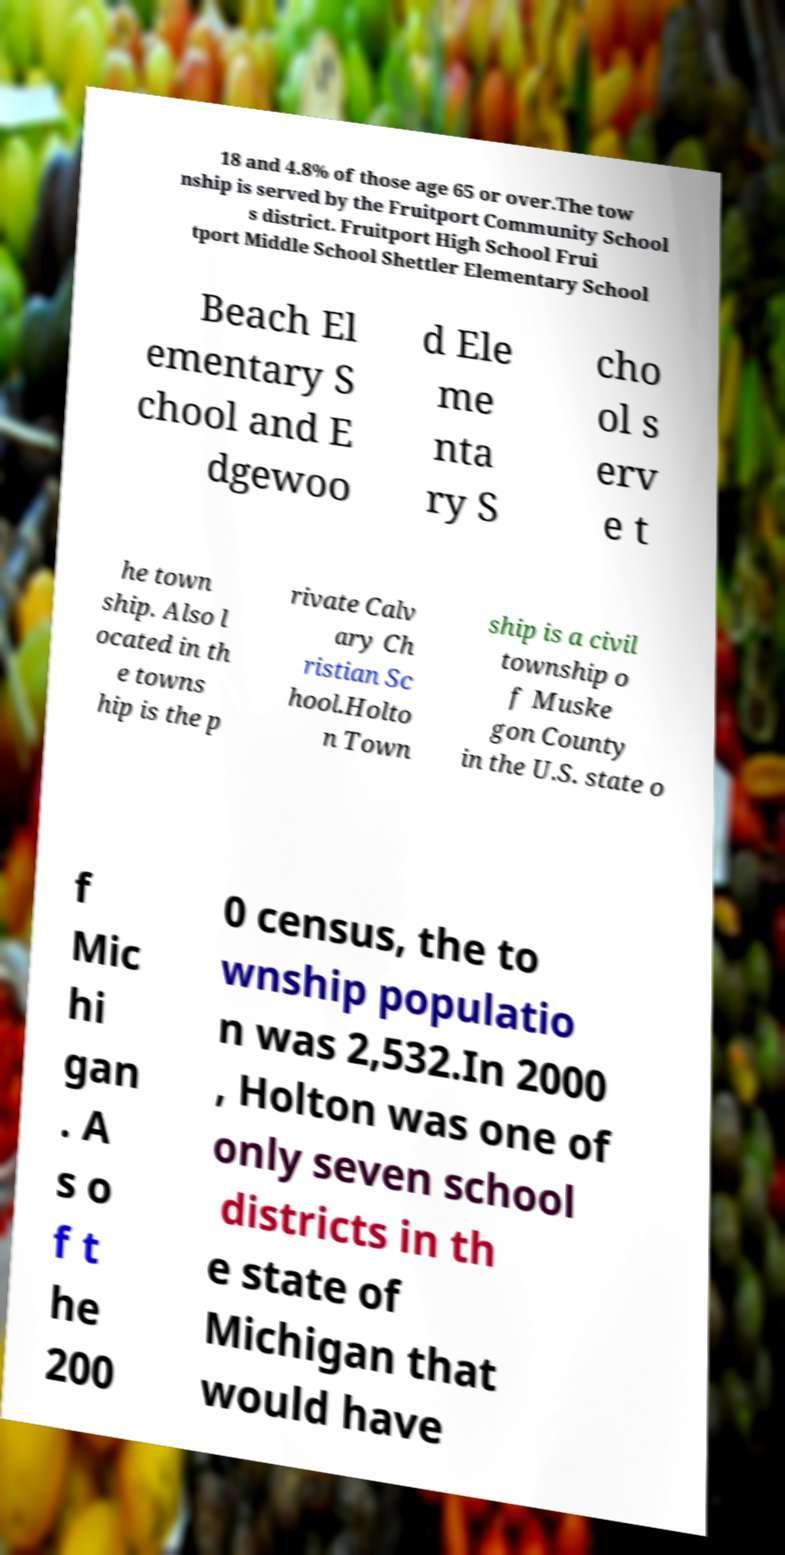I need the written content from this picture converted into text. Can you do that? 18 and 4.8% of those age 65 or over.The tow nship is served by the Fruitport Community School s district. Fruitport High School Frui tport Middle School Shettler Elementary School Beach El ementary S chool and E dgewoo d Ele me nta ry S cho ol s erv e t he town ship. Also l ocated in th e towns hip is the p rivate Calv ary Ch ristian Sc hool.Holto n Town ship is a civil township o f Muske gon County in the U.S. state o f Mic hi gan . A s o f t he 200 0 census, the to wnship populatio n was 2,532.In 2000 , Holton was one of only seven school districts in th e state of Michigan that would have 